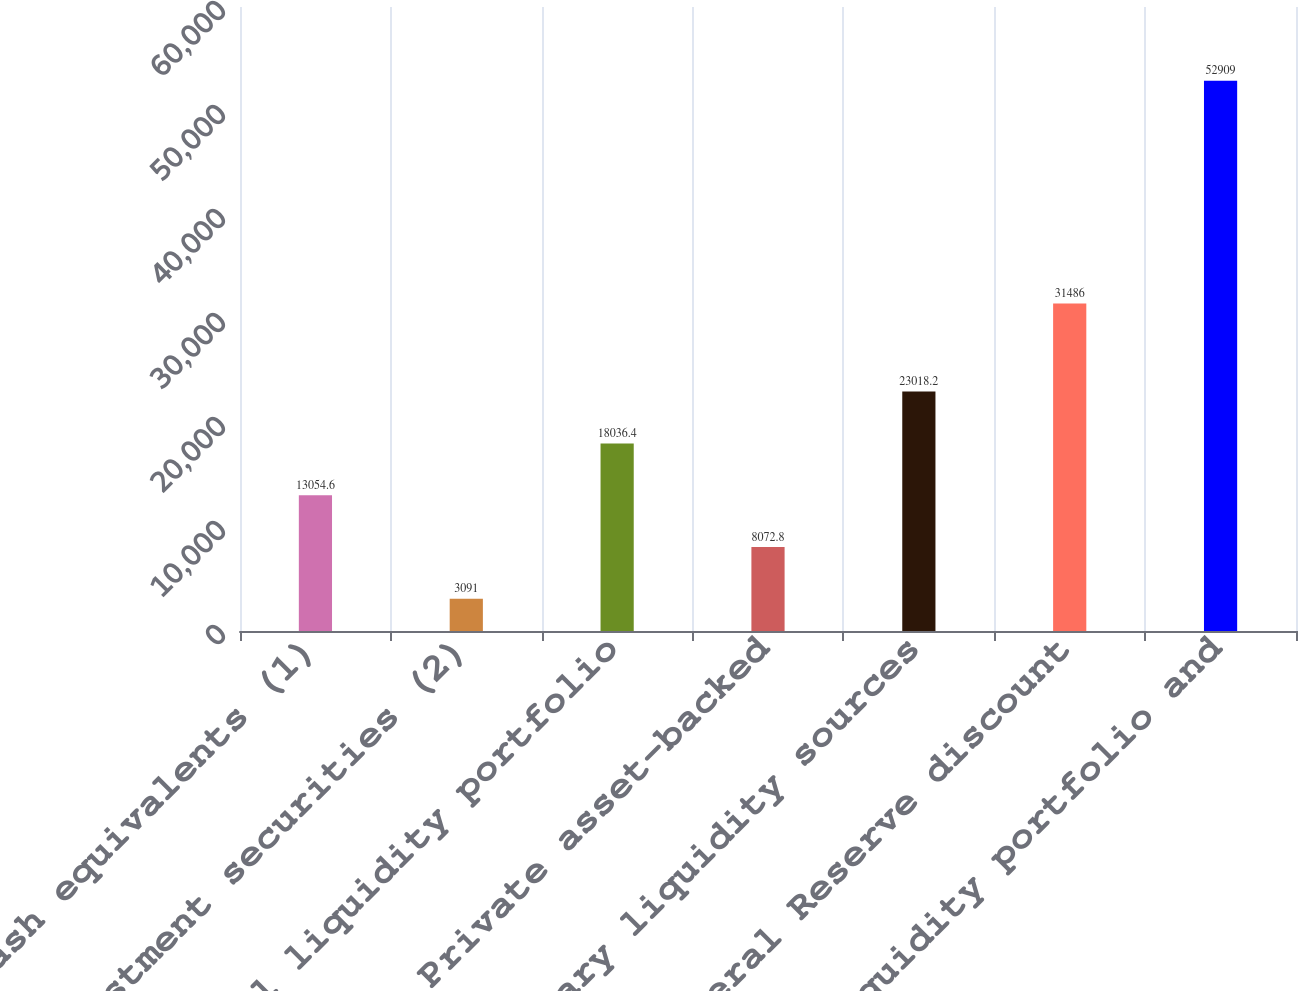Convert chart. <chart><loc_0><loc_0><loc_500><loc_500><bar_chart><fcel>Cash and cash equivalents (1)<fcel>Investment securities (2)<fcel>Total liquidity portfolio<fcel>Private asset-backed<fcel>Primary liquidity sources<fcel>Federal Reserve discount<fcel>Total liquidity portfolio and<nl><fcel>13054.6<fcel>3091<fcel>18036.4<fcel>8072.8<fcel>23018.2<fcel>31486<fcel>52909<nl></chart> 